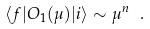<formula> <loc_0><loc_0><loc_500><loc_500>\langle f | O _ { 1 } ( \mu ) | i \rangle \sim \mu ^ { n } \ .</formula> 